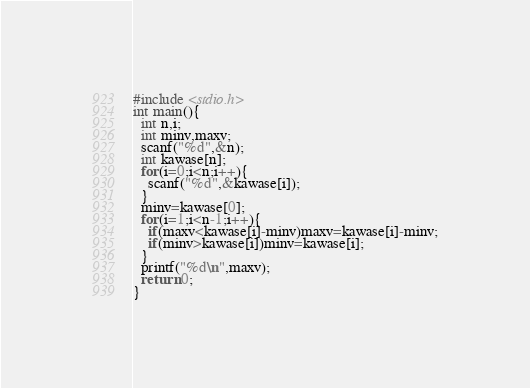Convert code to text. <code><loc_0><loc_0><loc_500><loc_500><_C_>#include <stdio.h>
int main(){
  int n,i;
  int minv,maxv;
  scanf("%d",&n);
  int kawase[n];
  for(i=0;i<n;i++){
    scanf("%d",&kawase[i]);
  }
  minv=kawase[0];
  for(i=1;i<n-1;i++){
    if(maxv<kawase[i]-minv)maxv=kawase[i]-minv;
    if(minv>kawase[i])minv=kawase[i];
  }
  printf("%d\n",maxv);
  return 0;
}</code> 